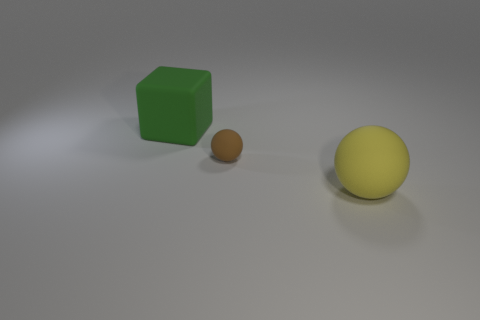Subtract all gray blocks. Subtract all gray spheres. How many blocks are left? 1 Add 2 big rubber spheres. How many objects exist? 5 Subtract all cubes. How many objects are left? 2 Add 1 tiny red cylinders. How many tiny red cylinders exist? 1 Subtract 0 gray spheres. How many objects are left? 3 Subtract all yellow cubes. Subtract all large green rubber things. How many objects are left? 2 Add 1 big yellow rubber spheres. How many big yellow rubber spheres are left? 2 